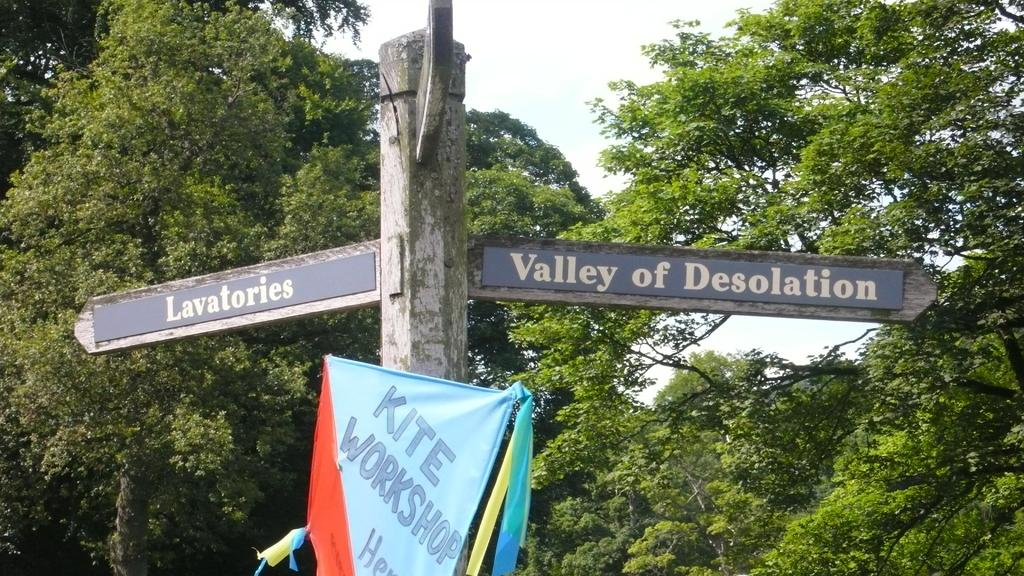What is the main subject in the middle of the image? There is a written text board in the middle of the image. What can be seen in the background of the image? There are groups of trees in the background of the image. What is visible at the top of the image? The sky is visible at the top of the image. What type of kettle is being used to attract visitors in the image? There is no kettle present in the image, and no attraction is mentioned or depicted. 